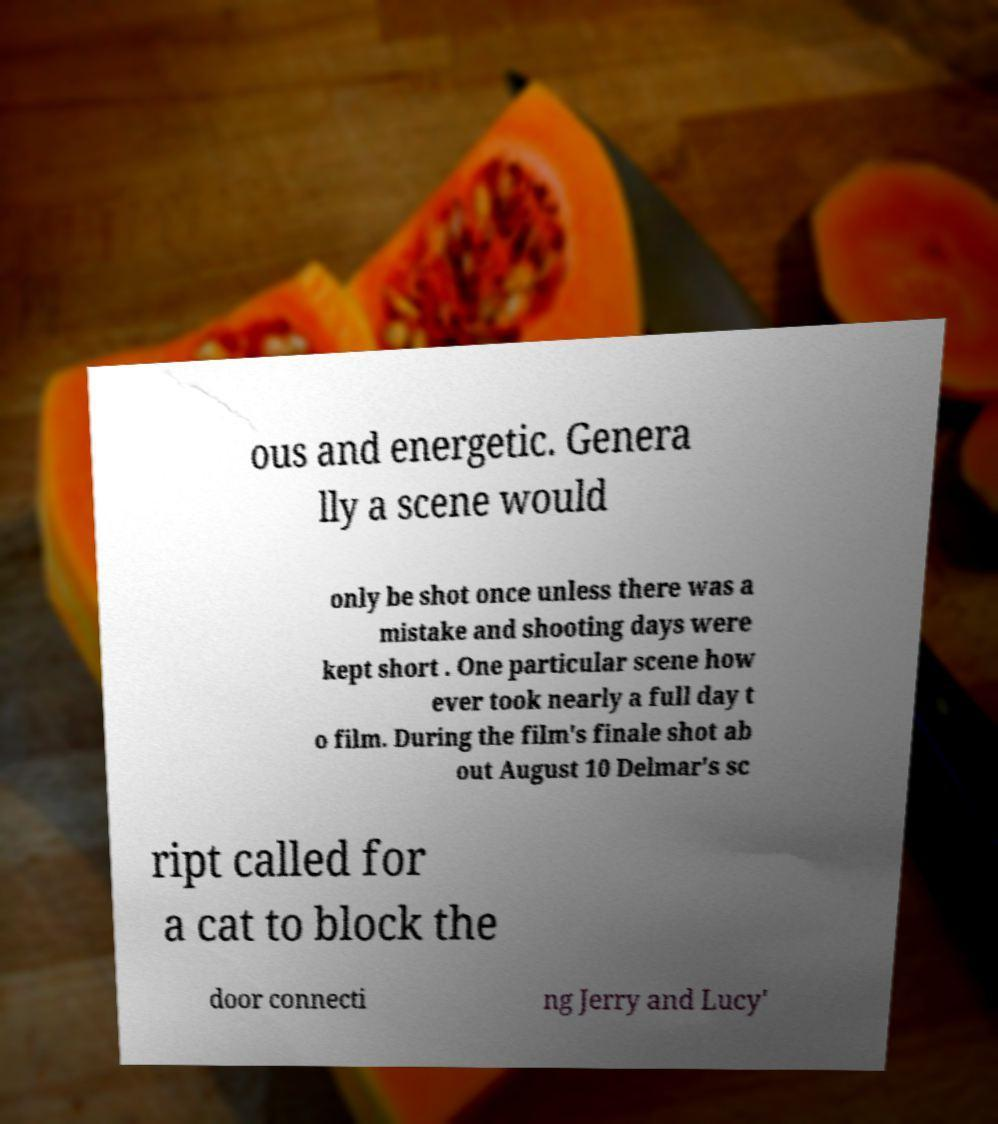There's text embedded in this image that I need extracted. Can you transcribe it verbatim? ous and energetic. Genera lly a scene would only be shot once unless there was a mistake and shooting days were kept short . One particular scene how ever took nearly a full day t o film. During the film's finale shot ab out August 10 Delmar's sc ript called for a cat to block the door connecti ng Jerry and Lucy' 